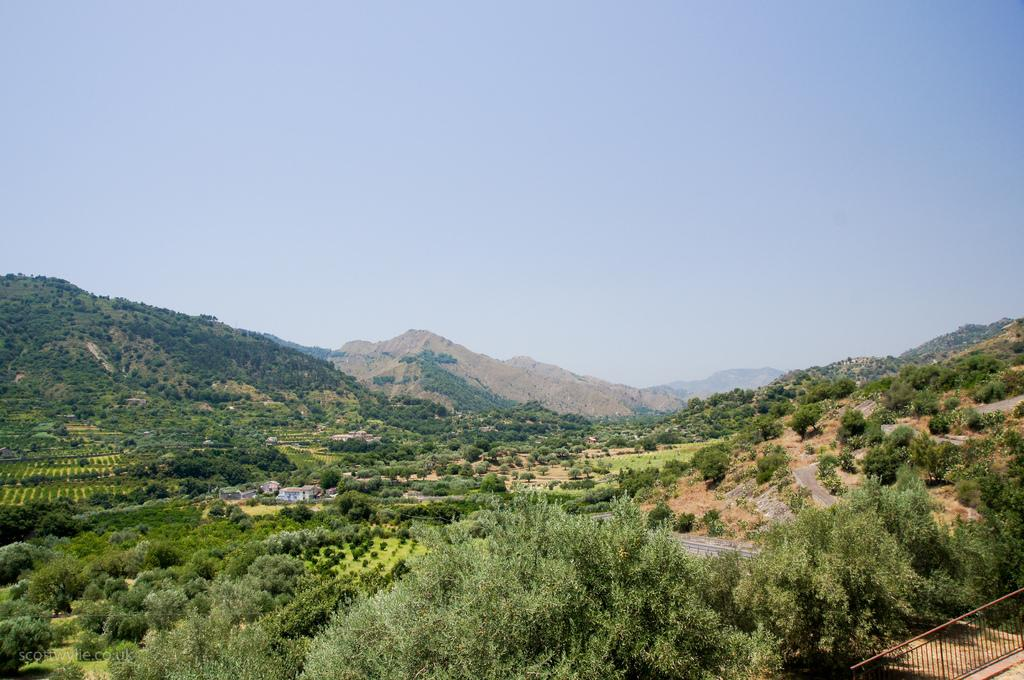What type of landscape is visible in the image? There is a hill view in the image. What else can be seen in the sky in the image? The sky is visible in the image. What type of vegetation is present in the image? Trees are visible in the image. How many horses can be seen grazing on the hill in the image? There are no horses present in the image; it only features a hill view, the sky, and trees. 